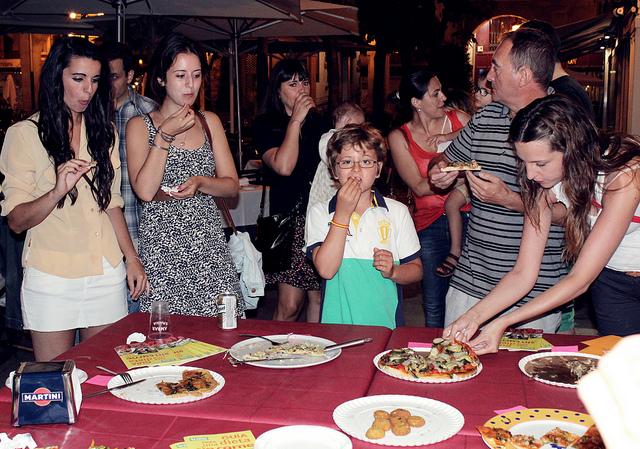What shape are the plates?
Write a very short answer. Round. Are these people eating?
Quick response, please. Yes. What color is the tablecloth?
Keep it brief. Red. 